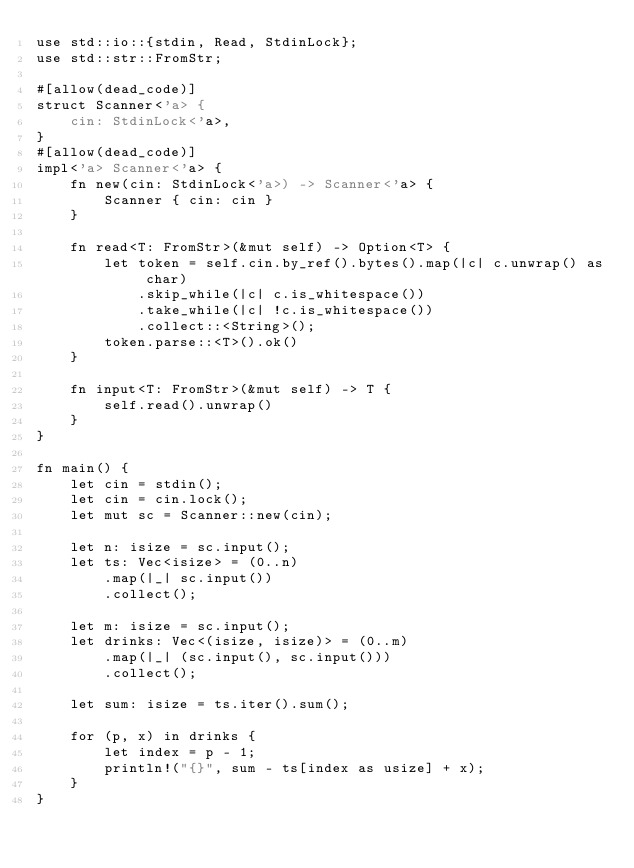Convert code to text. <code><loc_0><loc_0><loc_500><loc_500><_Rust_>use std::io::{stdin, Read, StdinLock};
use std::str::FromStr;

#[allow(dead_code)]
struct Scanner<'a> {
    cin: StdinLock<'a>,
}
#[allow(dead_code)]
impl<'a> Scanner<'a> {
    fn new(cin: StdinLock<'a>) -> Scanner<'a> {
        Scanner { cin: cin }
    }

    fn read<T: FromStr>(&mut self) -> Option<T> {
        let token = self.cin.by_ref().bytes().map(|c| c.unwrap() as char)
            .skip_while(|c| c.is_whitespace())
            .take_while(|c| !c.is_whitespace())
            .collect::<String>();
        token.parse::<T>().ok()
    }

    fn input<T: FromStr>(&mut self) -> T {
        self.read().unwrap()
    }
}

fn main() {
    let cin = stdin();
    let cin = cin.lock();
    let mut sc = Scanner::new(cin);

    let n: isize = sc.input();
    let ts: Vec<isize> = (0..n)
        .map(|_| sc.input())
        .collect();

    let m: isize = sc.input();
    let drinks: Vec<(isize, isize)> = (0..m)
        .map(|_| (sc.input(), sc.input()))
        .collect();

    let sum: isize = ts.iter().sum();

    for (p, x) in drinks {
        let index = p - 1;
        println!("{}", sum - ts[index as usize] + x);
    }
}
</code> 